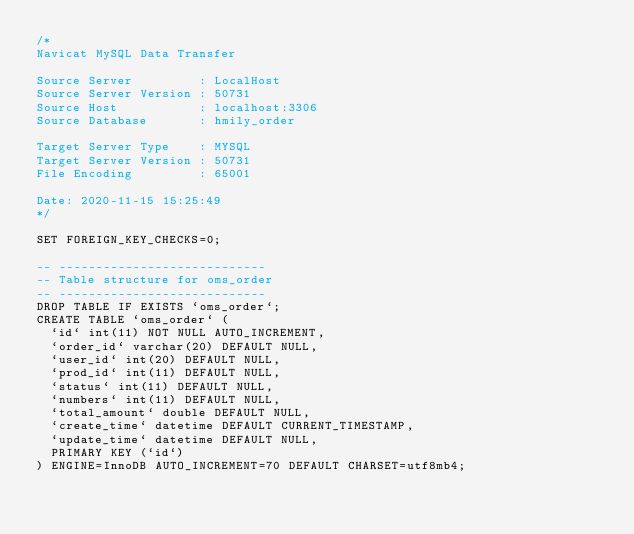<code> <loc_0><loc_0><loc_500><loc_500><_SQL_>/*
Navicat MySQL Data Transfer

Source Server         : LocalHost
Source Server Version : 50731
Source Host           : localhost:3306
Source Database       : hmily_order

Target Server Type    : MYSQL
Target Server Version : 50731
File Encoding         : 65001

Date: 2020-11-15 15:25:49
*/

SET FOREIGN_KEY_CHECKS=0;

-- ----------------------------
-- Table structure for oms_order
-- ----------------------------
DROP TABLE IF EXISTS `oms_order`;
CREATE TABLE `oms_order` (
  `id` int(11) NOT NULL AUTO_INCREMENT,
  `order_id` varchar(20) DEFAULT NULL,
  `user_id` int(20) DEFAULT NULL,
  `prod_id` int(11) DEFAULT NULL,
  `status` int(11) DEFAULT NULL,
  `numbers` int(11) DEFAULT NULL,
  `total_amount` double DEFAULT NULL,
  `create_time` datetime DEFAULT CURRENT_TIMESTAMP,
  `update_time` datetime DEFAULT NULL,
  PRIMARY KEY (`id`)
) ENGINE=InnoDB AUTO_INCREMENT=70 DEFAULT CHARSET=utf8mb4;
</code> 